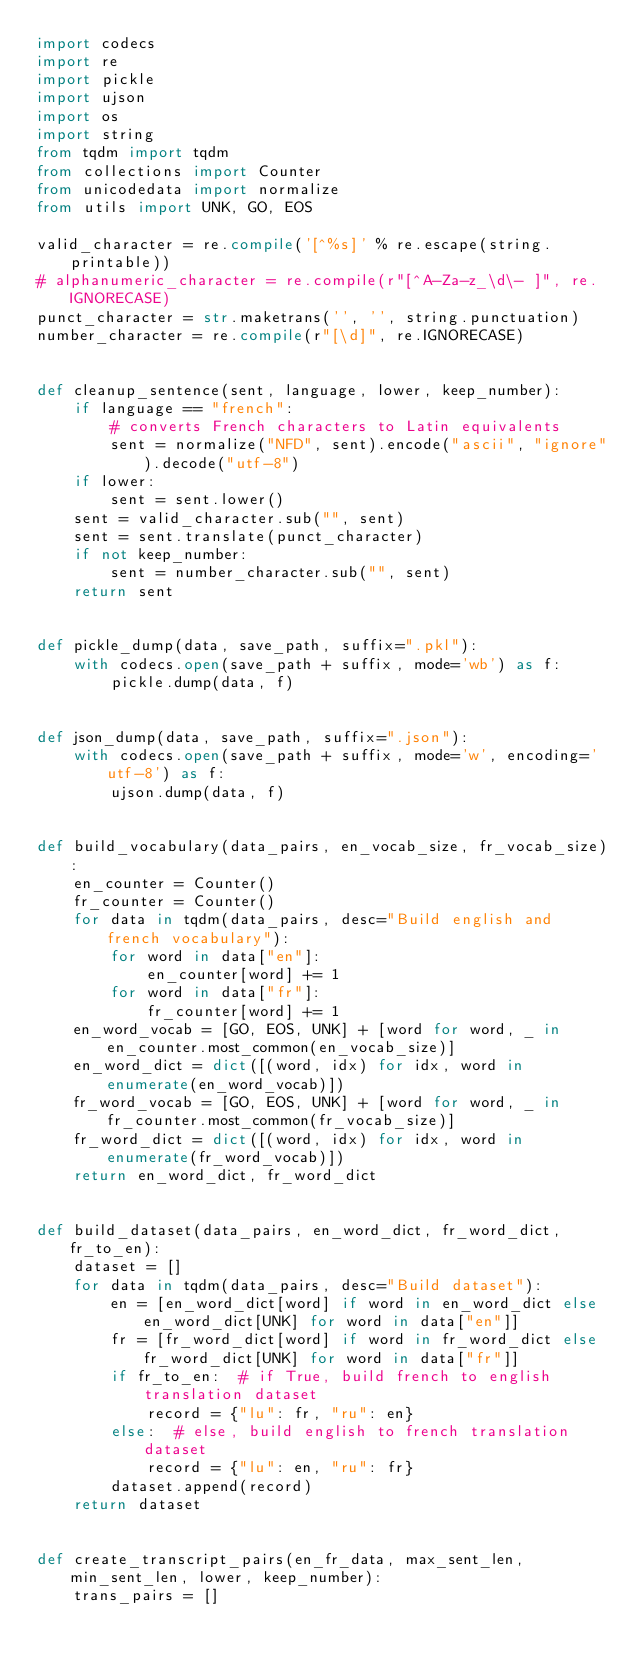<code> <loc_0><loc_0><loc_500><loc_500><_Python_>import codecs
import re
import pickle
import ujson
import os
import string
from tqdm import tqdm
from collections import Counter
from unicodedata import normalize
from utils import UNK, GO, EOS

valid_character = re.compile('[^%s]' % re.escape(string.printable))
# alphanumeric_character = re.compile(r"[^A-Za-z_\d\- ]", re.IGNORECASE)
punct_character = str.maketrans('', '', string.punctuation)
number_character = re.compile(r"[\d]", re.IGNORECASE)


def cleanup_sentence(sent, language, lower, keep_number):
    if language == "french":
        # converts French characters to Latin equivalents
        sent = normalize("NFD", sent).encode("ascii", "ignore").decode("utf-8")
    if lower:
        sent = sent.lower()
    sent = valid_character.sub("", sent)
    sent = sent.translate(punct_character)
    if not keep_number:
        sent = number_character.sub("", sent)
    return sent


def pickle_dump(data, save_path, suffix=".pkl"):
    with codecs.open(save_path + suffix, mode='wb') as f:
        pickle.dump(data, f)


def json_dump(data, save_path, suffix=".json"):
    with codecs.open(save_path + suffix, mode='w', encoding='utf-8') as f:
        ujson.dump(data, f)


def build_vocabulary(data_pairs, en_vocab_size, fr_vocab_size):
    en_counter = Counter()
    fr_counter = Counter()
    for data in tqdm(data_pairs, desc="Build english and french vocabulary"):
        for word in data["en"]:
            en_counter[word] += 1
        for word in data["fr"]:
            fr_counter[word] += 1
    en_word_vocab = [GO, EOS, UNK] + [word for word, _ in en_counter.most_common(en_vocab_size)]
    en_word_dict = dict([(word, idx) for idx, word in enumerate(en_word_vocab)])
    fr_word_vocab = [GO, EOS, UNK] + [word for word, _ in fr_counter.most_common(fr_vocab_size)]
    fr_word_dict = dict([(word, idx) for idx, word in enumerate(fr_word_vocab)])
    return en_word_dict, fr_word_dict


def build_dataset(data_pairs, en_word_dict, fr_word_dict, fr_to_en):
    dataset = []
    for data in tqdm(data_pairs, desc="Build dataset"):
        en = [en_word_dict[word] if word in en_word_dict else en_word_dict[UNK] for word in data["en"]]
        fr = [fr_word_dict[word] if word in fr_word_dict else fr_word_dict[UNK] for word in data["fr"]]
        if fr_to_en:  # if True, build french to english translation dataset
            record = {"lu": fr, "ru": en}
        else:  # else, build english to french translation dataset
            record = {"lu": en, "ru": fr}
        dataset.append(record)
    return dataset


def create_transcript_pairs(en_fr_data, max_sent_len, min_sent_len, lower, keep_number):
    trans_pairs = []</code> 